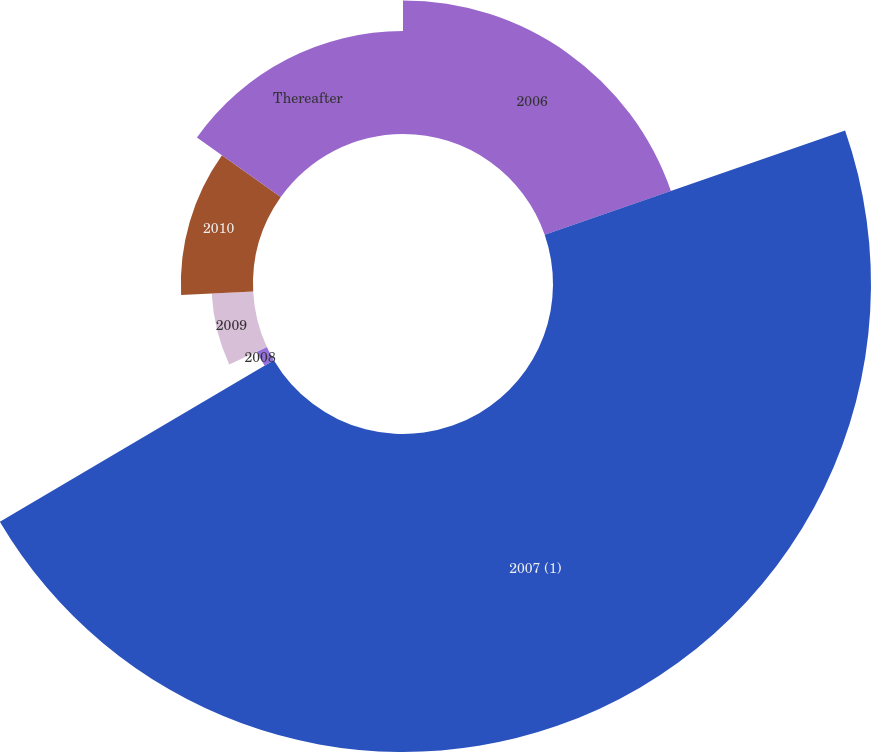Convert chart to OTSL. <chart><loc_0><loc_0><loc_500><loc_500><pie_chart><fcel>2006<fcel>2007 (1)<fcel>2008<fcel>2009<fcel>2010<fcel>Thereafter<nl><fcel>19.68%<fcel>46.84%<fcel>1.58%<fcel>6.11%<fcel>10.63%<fcel>15.16%<nl></chart> 